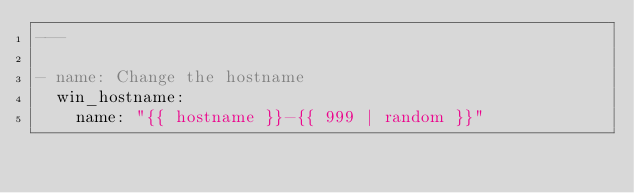Convert code to text. <code><loc_0><loc_0><loc_500><loc_500><_YAML_>---

- name: Change the hostname
  win_hostname:
    name: "{{ hostname }}-{{ 999 | random }}"
</code> 